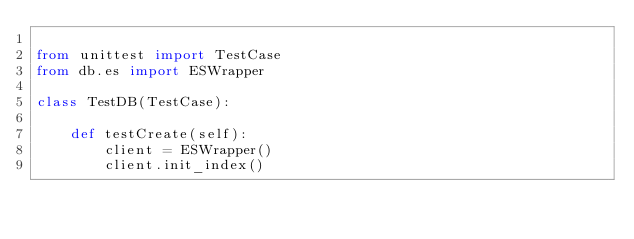<code> <loc_0><loc_0><loc_500><loc_500><_Python_>
from unittest import TestCase
from db.es import ESWrapper

class TestDB(TestCase):

    def testCreate(self):
        client = ESWrapper()
        client.init_index()</code> 